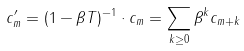<formula> <loc_0><loc_0><loc_500><loc_500>c ^ { \prime } _ { m } = ( 1 - \beta T ) ^ { - 1 } \cdot c _ { m } = \sum _ { k \geq 0 } \beta ^ { k } c _ { m + k }</formula> 